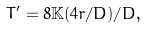Convert formula to latex. <formula><loc_0><loc_0><loc_500><loc_500>T ^ { \prime } = 8 { \mathbb { K } } ( 4 r / D ) / D ,</formula> 